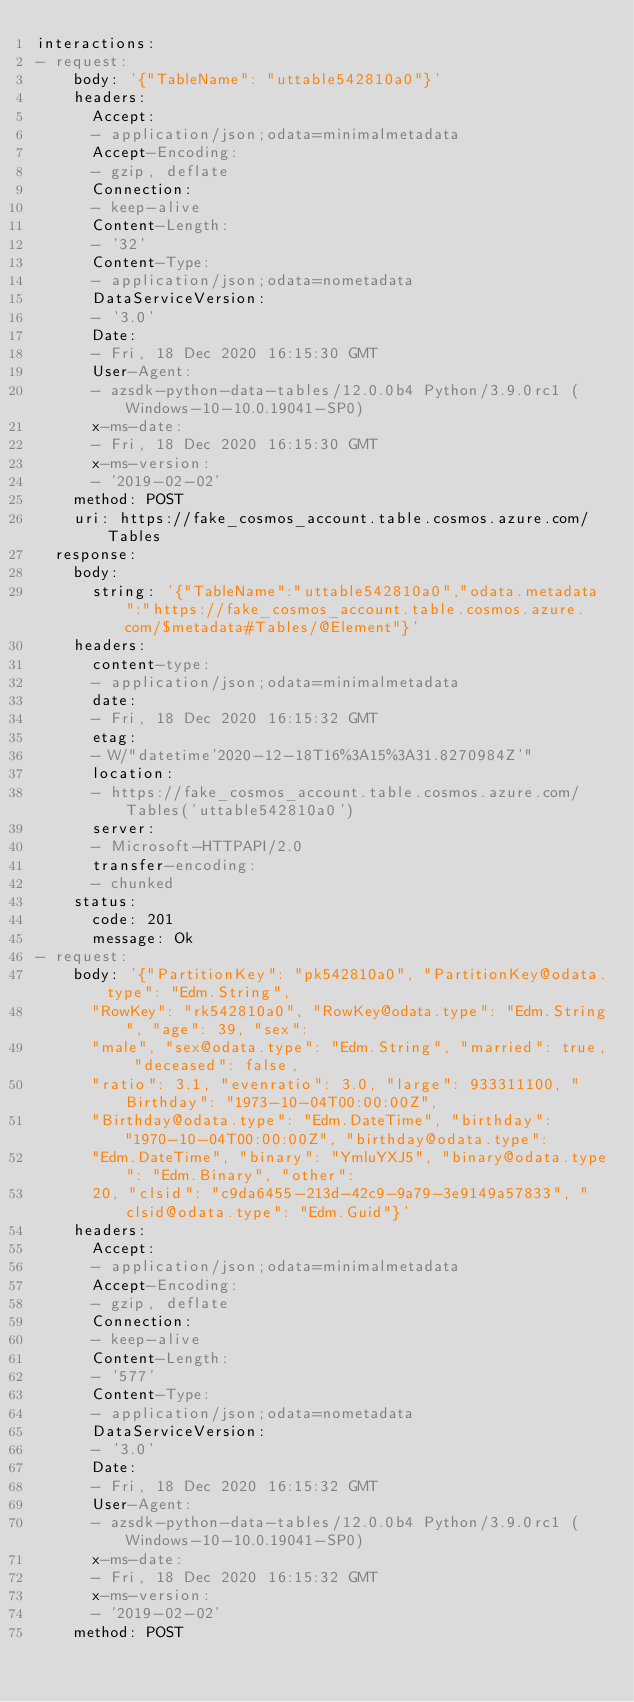Convert code to text. <code><loc_0><loc_0><loc_500><loc_500><_YAML_>interactions:
- request:
    body: '{"TableName": "uttable542810a0"}'
    headers:
      Accept:
      - application/json;odata=minimalmetadata
      Accept-Encoding:
      - gzip, deflate
      Connection:
      - keep-alive
      Content-Length:
      - '32'
      Content-Type:
      - application/json;odata=nometadata
      DataServiceVersion:
      - '3.0'
      Date:
      - Fri, 18 Dec 2020 16:15:30 GMT
      User-Agent:
      - azsdk-python-data-tables/12.0.0b4 Python/3.9.0rc1 (Windows-10-10.0.19041-SP0)
      x-ms-date:
      - Fri, 18 Dec 2020 16:15:30 GMT
      x-ms-version:
      - '2019-02-02'
    method: POST
    uri: https://fake_cosmos_account.table.cosmos.azure.com/Tables
  response:
    body:
      string: '{"TableName":"uttable542810a0","odata.metadata":"https://fake_cosmos_account.table.cosmos.azure.com/$metadata#Tables/@Element"}'
    headers:
      content-type:
      - application/json;odata=minimalmetadata
      date:
      - Fri, 18 Dec 2020 16:15:32 GMT
      etag:
      - W/"datetime'2020-12-18T16%3A15%3A31.8270984Z'"
      location:
      - https://fake_cosmos_account.table.cosmos.azure.com/Tables('uttable542810a0')
      server:
      - Microsoft-HTTPAPI/2.0
      transfer-encoding:
      - chunked
    status:
      code: 201
      message: Ok
- request:
    body: '{"PartitionKey": "pk542810a0", "PartitionKey@odata.type": "Edm.String",
      "RowKey": "rk542810a0", "RowKey@odata.type": "Edm.String", "age": 39, "sex":
      "male", "sex@odata.type": "Edm.String", "married": true, "deceased": false,
      "ratio": 3.1, "evenratio": 3.0, "large": 933311100, "Birthday": "1973-10-04T00:00:00Z",
      "Birthday@odata.type": "Edm.DateTime", "birthday": "1970-10-04T00:00:00Z", "birthday@odata.type":
      "Edm.DateTime", "binary": "YmluYXJ5", "binary@odata.type": "Edm.Binary", "other":
      20, "clsid": "c9da6455-213d-42c9-9a79-3e9149a57833", "clsid@odata.type": "Edm.Guid"}'
    headers:
      Accept:
      - application/json;odata=minimalmetadata
      Accept-Encoding:
      - gzip, deflate
      Connection:
      - keep-alive
      Content-Length:
      - '577'
      Content-Type:
      - application/json;odata=nometadata
      DataServiceVersion:
      - '3.0'
      Date:
      - Fri, 18 Dec 2020 16:15:32 GMT
      User-Agent:
      - azsdk-python-data-tables/12.0.0b4 Python/3.9.0rc1 (Windows-10-10.0.19041-SP0)
      x-ms-date:
      - Fri, 18 Dec 2020 16:15:32 GMT
      x-ms-version:
      - '2019-02-02'
    method: POST</code> 